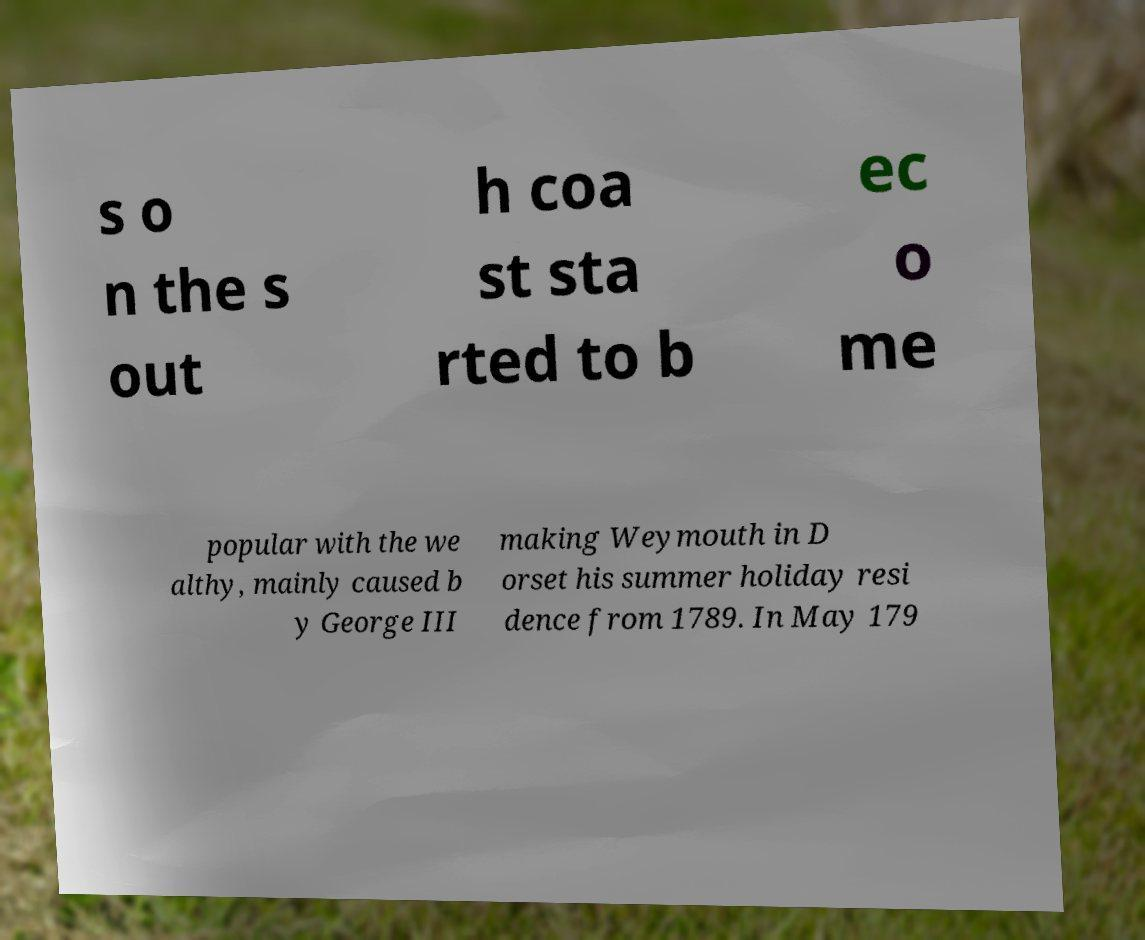For documentation purposes, I need the text within this image transcribed. Could you provide that? s o n the s out h coa st sta rted to b ec o me popular with the we althy, mainly caused b y George III making Weymouth in D orset his summer holiday resi dence from 1789. In May 179 